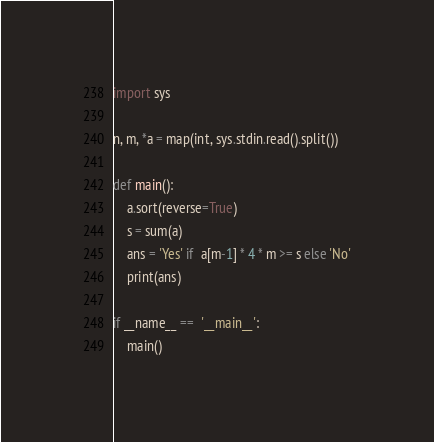Convert code to text. <code><loc_0><loc_0><loc_500><loc_500><_Python_>import sys

n, m, *a = map(int, sys.stdin.read().split())

def main():
    a.sort(reverse=True)
    s = sum(a)
    ans = 'Yes' if  a[m-1] * 4 * m >= s else 'No'
    print(ans)

if __name__ ==  '__main__':
    main()
</code> 